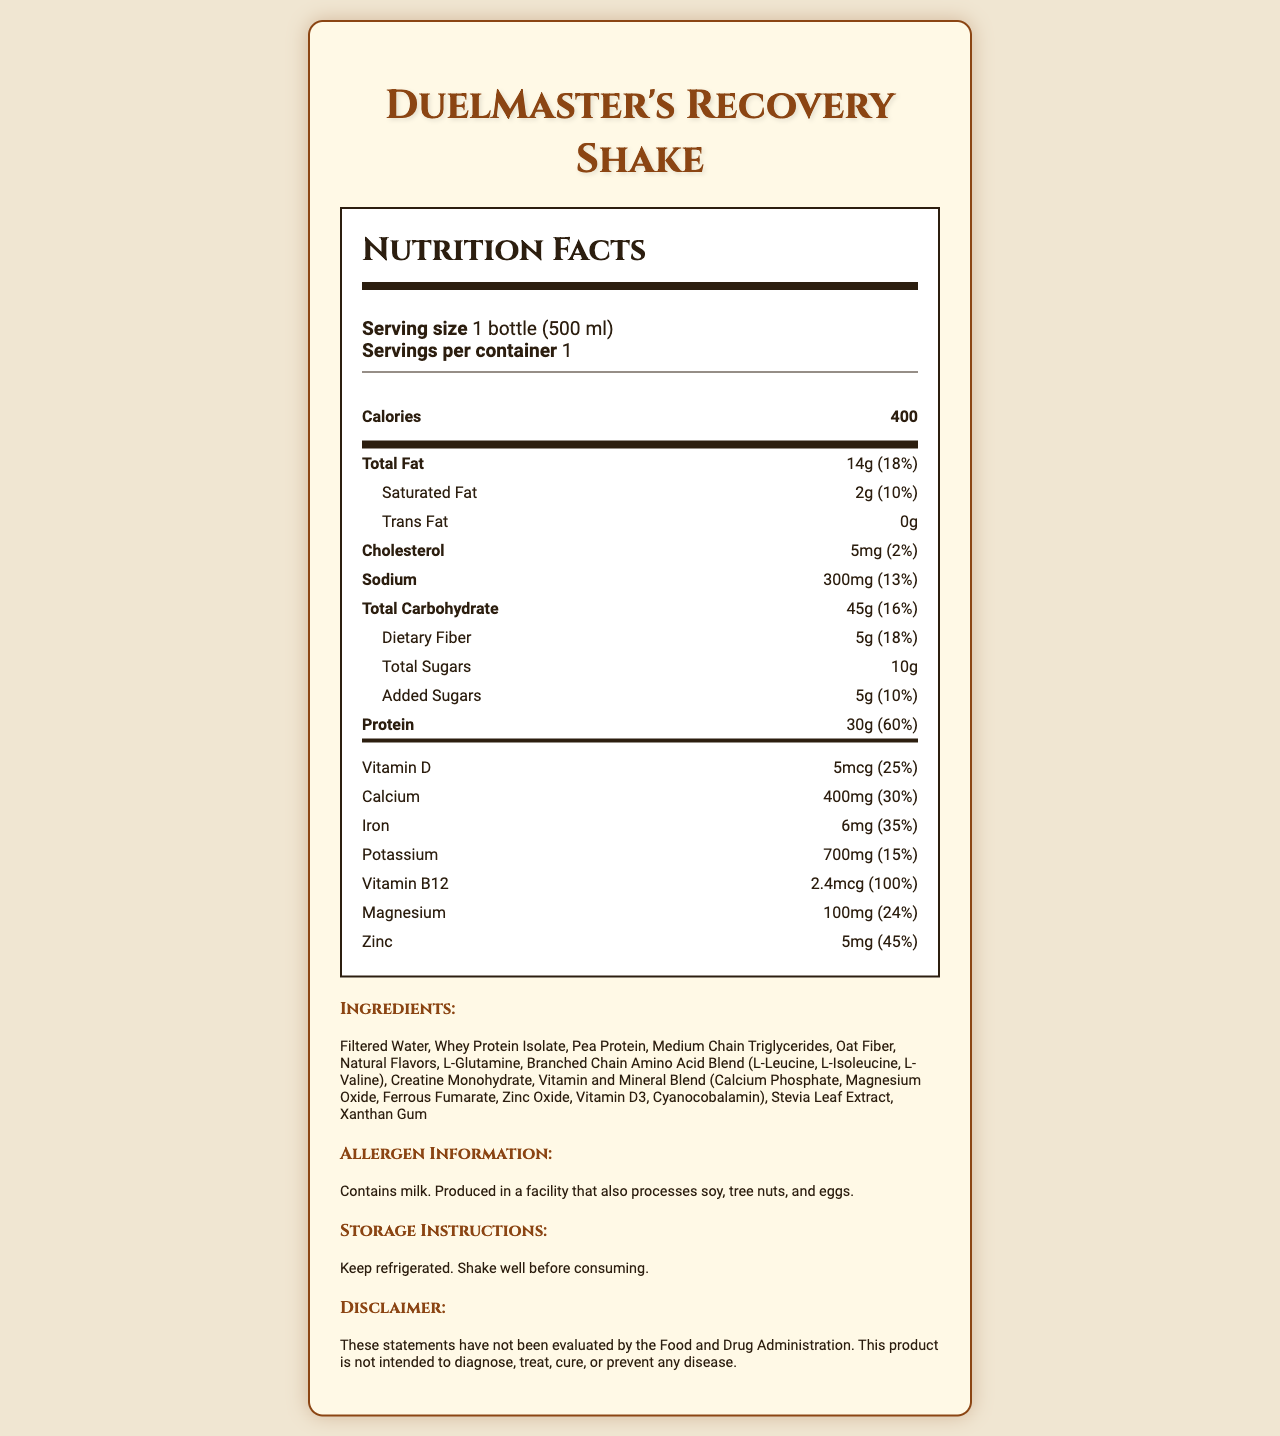what is the serving size of the DuelMaster's Recovery Shake? The serving size is listed near the top of the nutrition facts under "Serving size".
Answer: 1 bottle (500 ml) how many grams of protein does the shake contain? The amount of protein is shown in the main section of the nutrition facts under "Protein".
Answer: 30g what percentage of the daily value for calcium does the shake provide? The daily value percentage for calcium is listed under the vitamins section as 30%.
Answer: 30% does this product contain any trans fat? The product's nutrition label shows "Trans Fat" with a corresponding value of "0g".
Answer: No what is the allergen information for this product? The allergen information is provided at the bottom of the document under "Allergen Information".
Answer: Contains milk. Produced in a facility that also processes soy, tree nuts, and eggs. which of the following vitamins is present in the highest daily value percentage?
A. Vitamin D
B. Vitamin B12
C. Magnesium
D. Zinc Vitamin B12 has the highest daily value percentage at 100%, compared to others like Vitamin D (25%), Magnesium (24%), and Zinc (45%).
Answer: B. Vitamin B12 what ingredient is listed first in the ingredient list? 
A. Filtered Water
B. Whey Protein Isolate
C. Stevia Leaf Extract
D. Oat Fiber The ingredients are listed in order, and the first ingredient is "Filtered Water".
Answer: A. Filtered Water does this product need to be refrigerated? The storage instructions part of the document specifies "Keep refrigerated.".
Answer: Yes summarize the nutritional benefits and main ingredients of this product. The explanation should cover key nutritional facts, such as calorie content, protein, vitamins, and minerals, as well as highlight important ingredients.
Answer: The DuelMaster's Recovery Shake is a nutrient-dense meal replacement with 400 calories per 500 ml bottle. It provides 30g of protein, significant amounts of vitamins and minerals like Vitamin B12 (100% daily value), calcium (30% daily value), and iron (35% daily value). The shake contains essential amino acids and creatine, which are beneficial for recovery after duels. Key ingredients include filtered water, whey protein isolate, pea protein, and a blend of vitamins and minerals. what specific amino acids are included in the BCAA blend in this shake? The document lists "Branched Chain Amino Acid Blend (L-Leucine, L-Isoleucine, L-Valine)" but does not specify the proportion or exact dosage details of each amino acid.
Answer: I don't know 